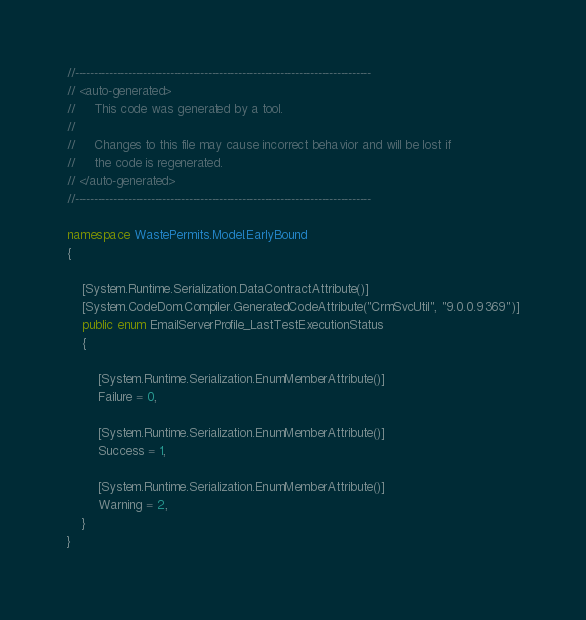<code> <loc_0><loc_0><loc_500><loc_500><_C#_>//------------------------------------------------------------------------------
// <auto-generated>
//     This code was generated by a tool.
//
//     Changes to this file may cause incorrect behavior and will be lost if
//     the code is regenerated.
// </auto-generated>
//------------------------------------------------------------------------------

namespace WastePermits.Model.EarlyBound
{
	
	[System.Runtime.Serialization.DataContractAttribute()]
	[System.CodeDom.Compiler.GeneratedCodeAttribute("CrmSvcUtil", "9.0.0.9369")]
	public enum EmailServerProfile_LastTestExecutionStatus
	{
		
		[System.Runtime.Serialization.EnumMemberAttribute()]
		Failure = 0,
		
		[System.Runtime.Serialization.EnumMemberAttribute()]
		Success = 1,
		
		[System.Runtime.Serialization.EnumMemberAttribute()]
		Warning = 2,
	}
}</code> 